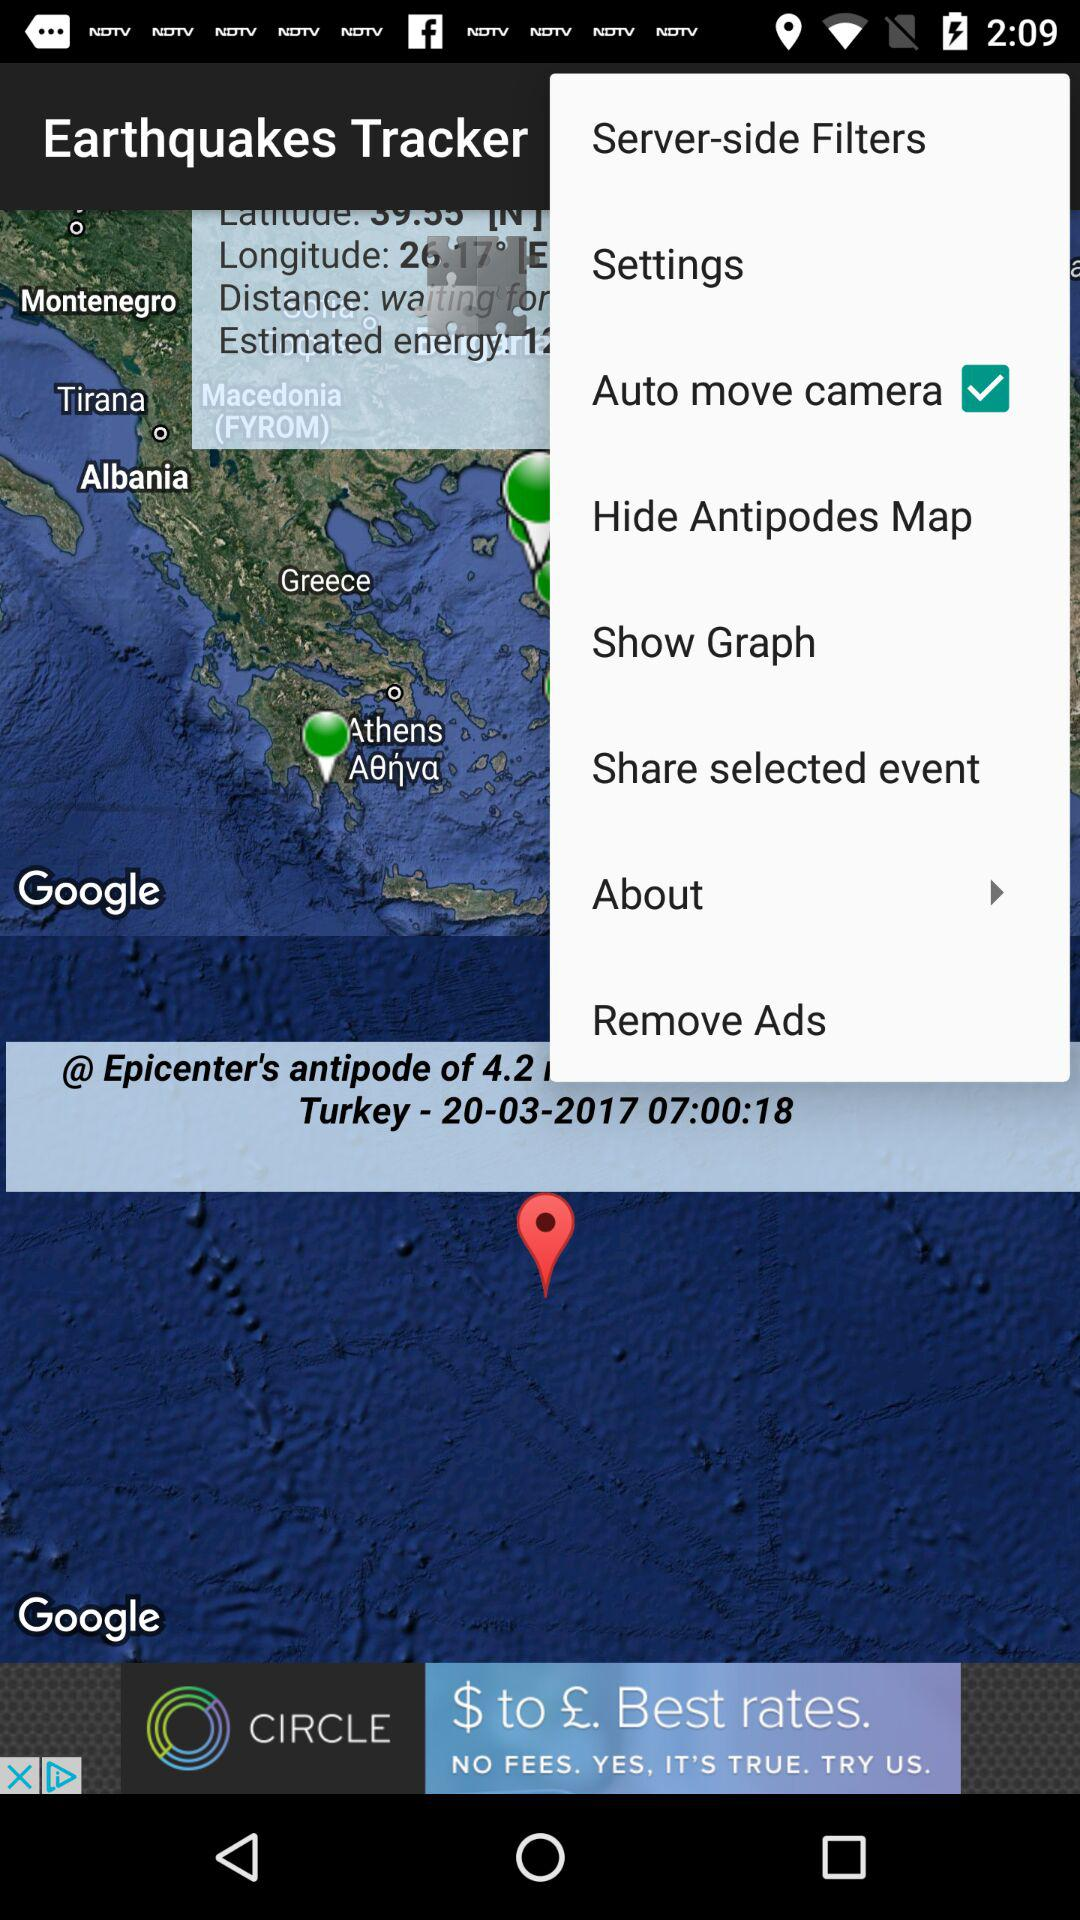What is the status of "Auto move camera"? The status is "on". 